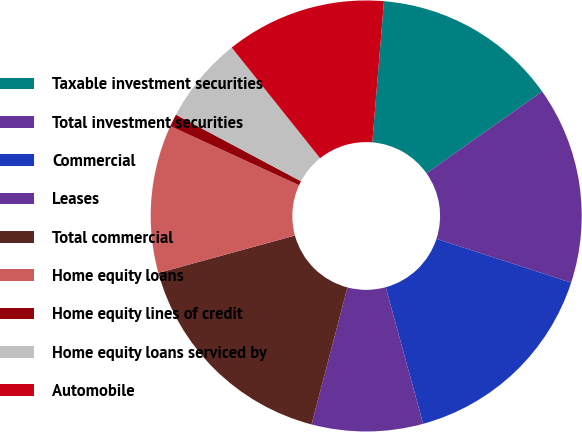Convert chart to OTSL. <chart><loc_0><loc_0><loc_500><loc_500><pie_chart><fcel>Taxable investment securities<fcel>Total investment securities<fcel>Commercial<fcel>Leases<fcel>Total commercial<fcel>Home equity loans<fcel>Home equity lines of credit<fcel>Home equity loans serviced by<fcel>Automobile<nl><fcel>13.89%<fcel>14.81%<fcel>15.74%<fcel>8.34%<fcel>16.66%<fcel>11.11%<fcel>0.94%<fcel>6.49%<fcel>12.04%<nl></chart> 